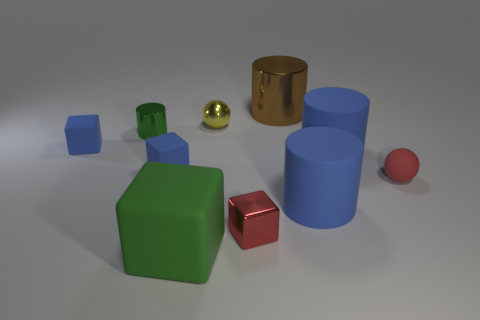Subtract 0 cyan cubes. How many objects are left? 10 Subtract all cylinders. How many objects are left? 6 Subtract 2 spheres. How many spheres are left? 0 Subtract all purple cylinders. Subtract all purple spheres. How many cylinders are left? 4 Subtract all purple balls. How many brown cylinders are left? 1 Subtract all blue things. Subtract all large green objects. How many objects are left? 5 Add 7 large rubber blocks. How many large rubber blocks are left? 8 Add 8 big metal spheres. How many big metal spheres exist? 8 Subtract all blue cylinders. How many cylinders are left? 2 Subtract all tiny cylinders. How many cylinders are left? 3 